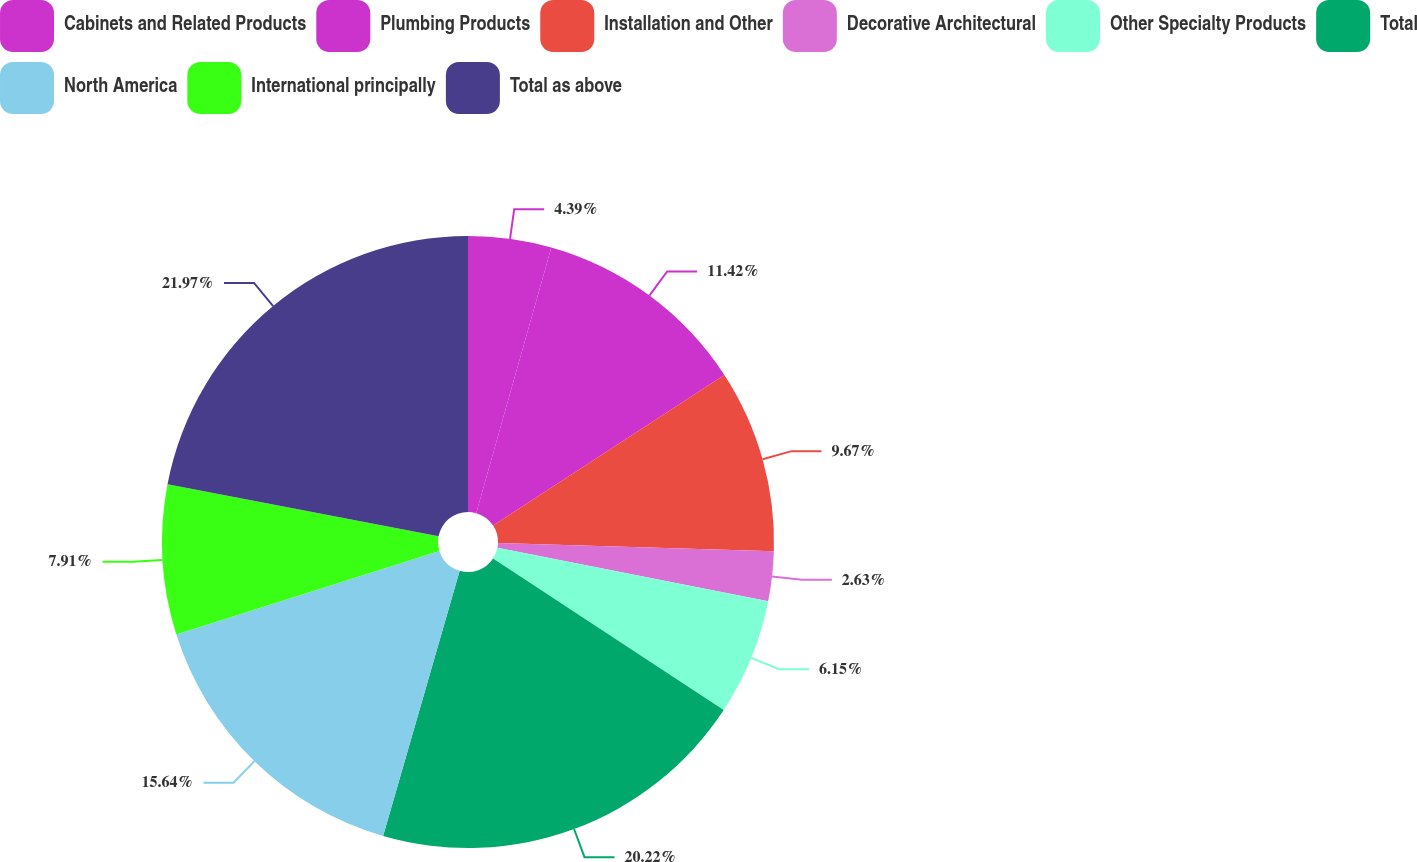<chart> <loc_0><loc_0><loc_500><loc_500><pie_chart><fcel>Cabinets and Related Products<fcel>Plumbing Products<fcel>Installation and Other<fcel>Decorative Architectural<fcel>Other Specialty Products<fcel>Total<fcel>North America<fcel>International principally<fcel>Total as above<nl><fcel>4.39%<fcel>11.42%<fcel>9.67%<fcel>2.63%<fcel>6.15%<fcel>20.22%<fcel>15.64%<fcel>7.91%<fcel>21.98%<nl></chart> 